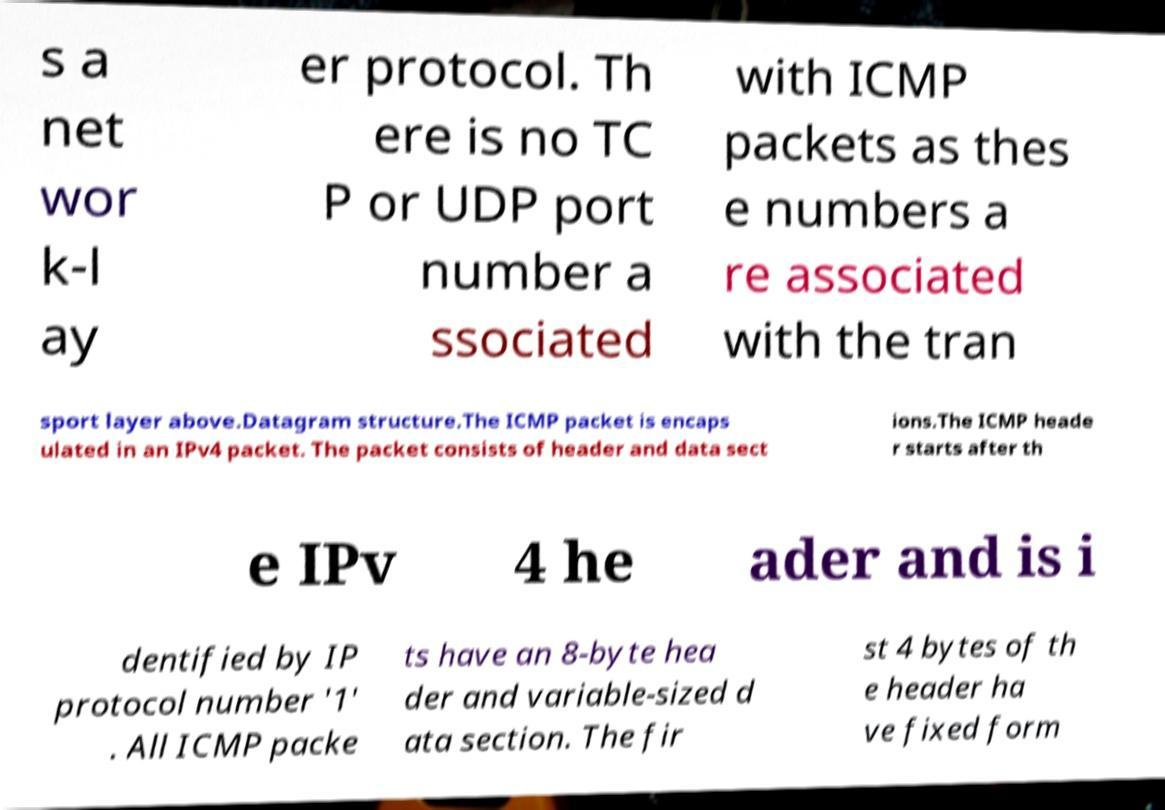Please identify and transcribe the text found in this image. s a net wor k-l ay er protocol. Th ere is no TC P or UDP port number a ssociated with ICMP packets as thes e numbers a re associated with the tran sport layer above.Datagram structure.The ICMP packet is encaps ulated in an IPv4 packet. The packet consists of header and data sect ions.The ICMP heade r starts after th e IPv 4 he ader and is i dentified by IP protocol number '1' . All ICMP packe ts have an 8-byte hea der and variable-sized d ata section. The fir st 4 bytes of th e header ha ve fixed form 